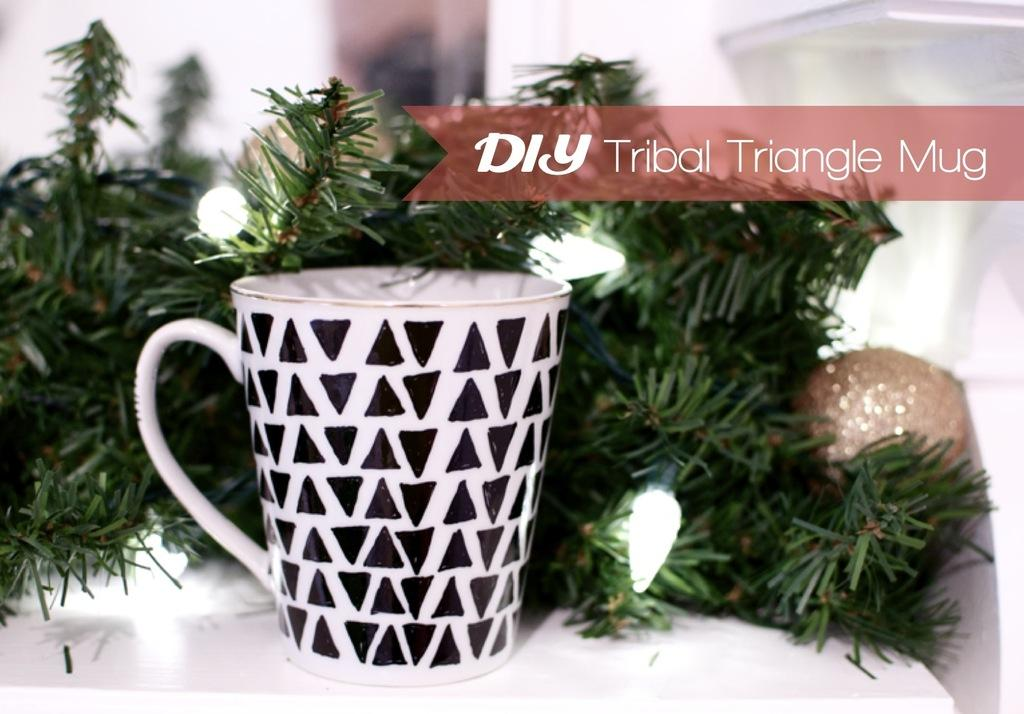What is on the table in the image? There is a coffee mug in the image. Where is the coffee mug located? The coffee mug is on a table. What is in front of the coffee mug? There are plants in front of the coffee mug. What can be seen in the image that provides light? There are lights visible in the image. How much oil is being traded in the image? There is no mention of oil or trading in the image; it features a coffee mug on a table with plants and lights. 